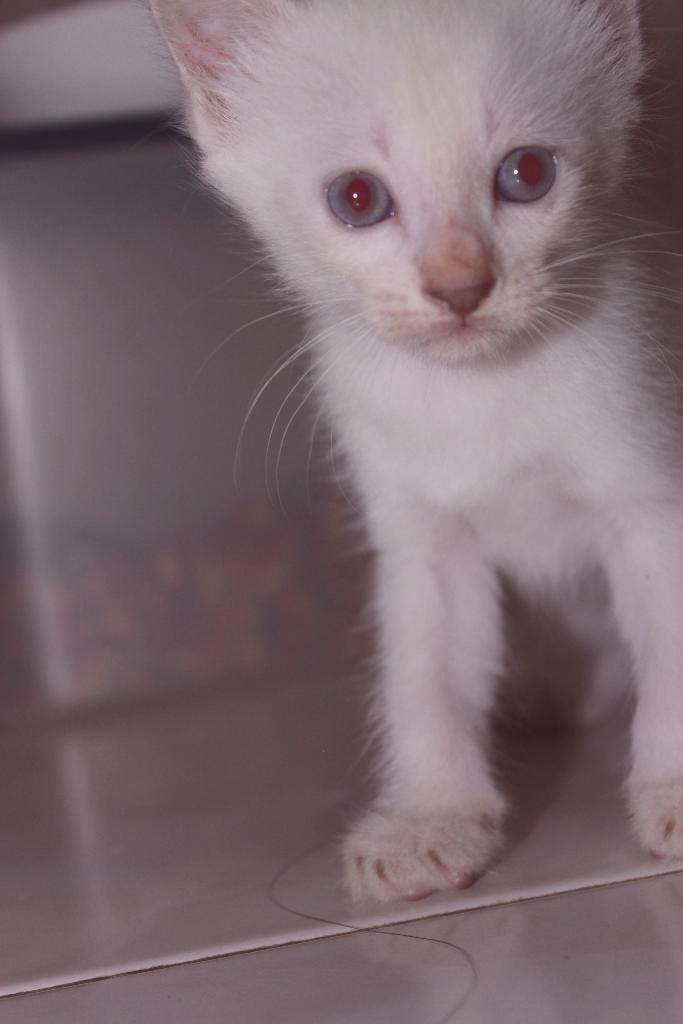What type of animal is in the image? There is a cat in the image. Can you describe the background of the image? The background of the image is blurry. How many deer can be seen in the image? There are no deer present in the image; it features a cat. What type of bun is visible in the image? There is no bun present in the image. 